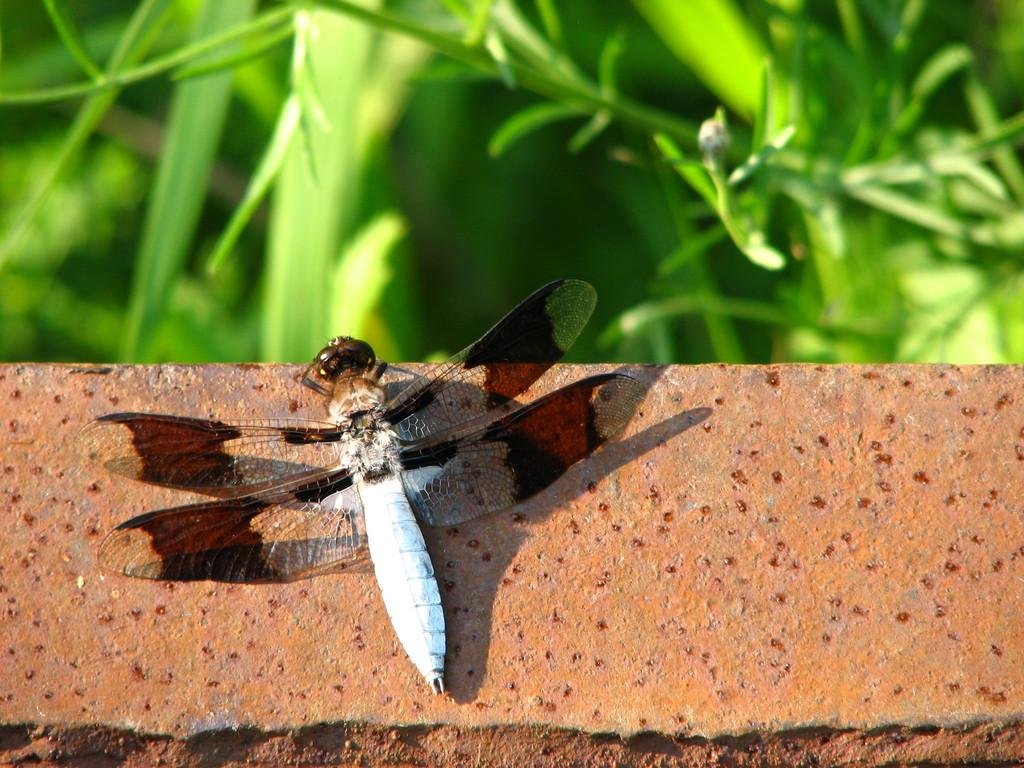What insect is present in the image? There is a dragonfly in the image. Where is the dragonfly located? The dragonfly is on an object that resembles a wall. What type of vegetation can be seen in the image? There are plants visible at the top of the image. Can you hear the dragonfly laugh in the image? There is no sound in the image, and dragonflies do not have the ability to laugh. 